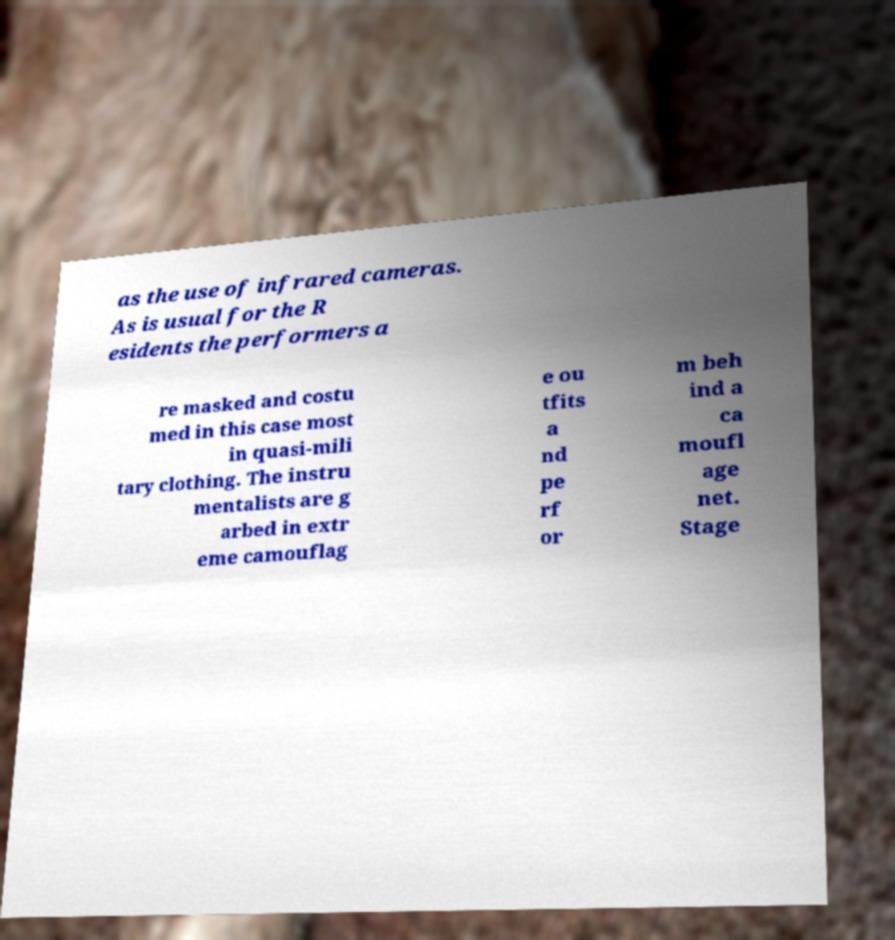Can you accurately transcribe the text from the provided image for me? as the use of infrared cameras. As is usual for the R esidents the performers a re masked and costu med in this case most in quasi-mili tary clothing. The instru mentalists are g arbed in extr eme camouflag e ou tfits a nd pe rf or m beh ind a ca moufl age net. Stage 